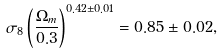Convert formula to latex. <formula><loc_0><loc_0><loc_500><loc_500>\sigma _ { 8 } \left ( \frac { \Omega _ { m } } { 0 . 3 } \right ) ^ { 0 . 4 2 \pm 0 . 0 1 } = 0 . 8 5 \pm 0 . 0 2 ,</formula> 